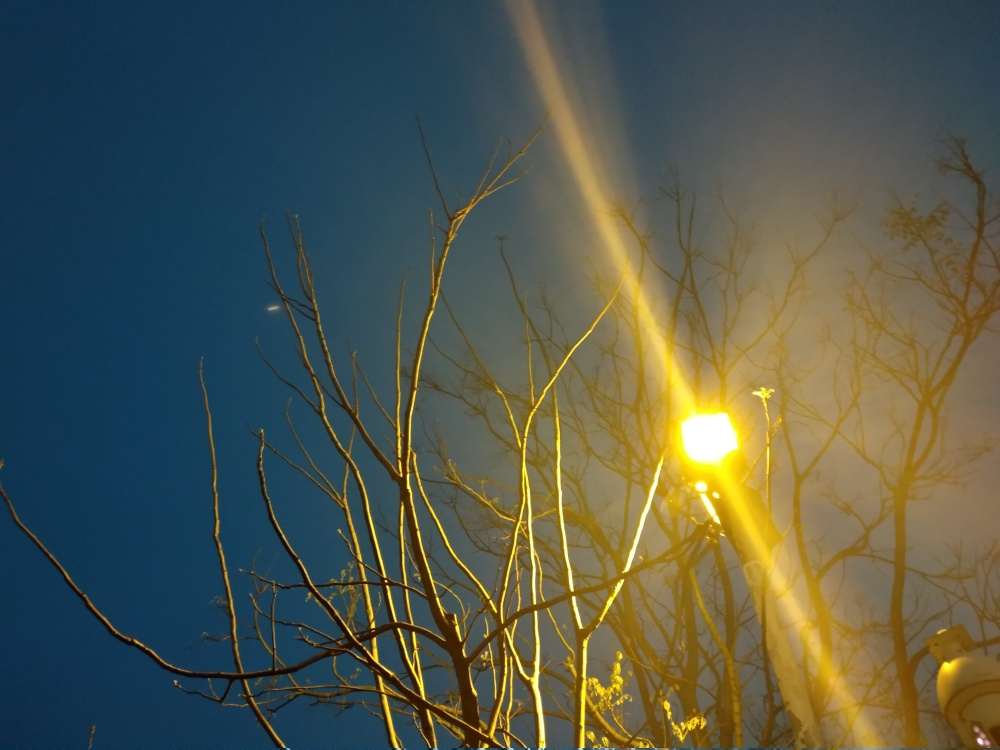Is the overall clarity of the photo acceptable? While the photo's artistic elements such as the contrasting warm street light against the cool blue of the twilight sky might be appealing, the sharpness is compromised due to the bright light source. This overexposure hampers the overall clarity, making some details difficult to discern. For a clearer image, avoiding direct light in the camera lens and using a lower ISO setting could help. 